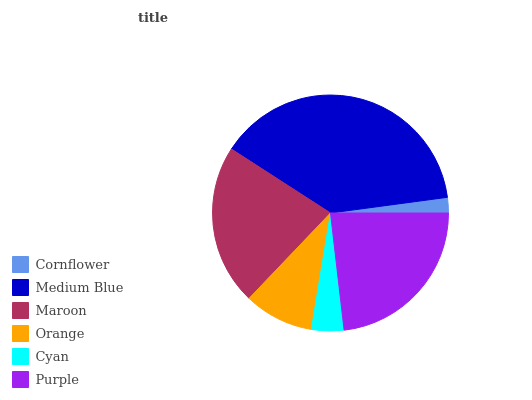Is Cornflower the minimum?
Answer yes or no. Yes. Is Medium Blue the maximum?
Answer yes or no. Yes. Is Maroon the minimum?
Answer yes or no. No. Is Maroon the maximum?
Answer yes or no. No. Is Medium Blue greater than Maroon?
Answer yes or no. Yes. Is Maroon less than Medium Blue?
Answer yes or no. Yes. Is Maroon greater than Medium Blue?
Answer yes or no. No. Is Medium Blue less than Maroon?
Answer yes or no. No. Is Maroon the high median?
Answer yes or no. Yes. Is Orange the low median?
Answer yes or no. Yes. Is Cornflower the high median?
Answer yes or no. No. Is Cornflower the low median?
Answer yes or no. No. 